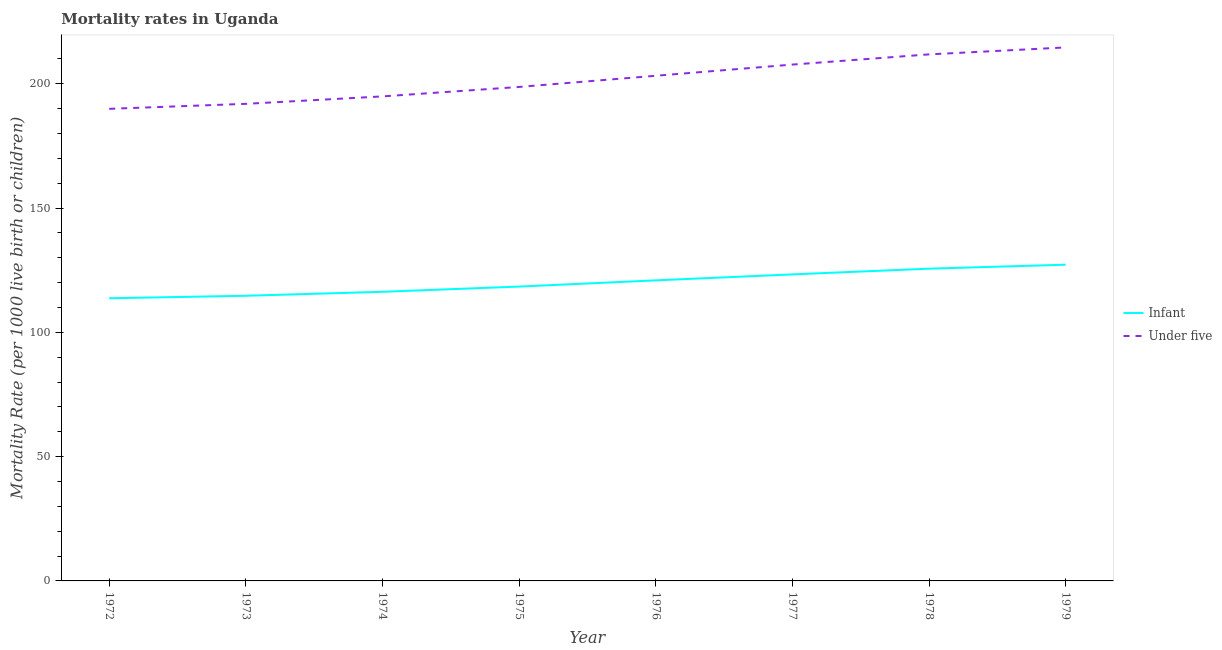How many different coloured lines are there?
Offer a very short reply. 2. Is the number of lines equal to the number of legend labels?
Your response must be concise. Yes. What is the under-5 mortality rate in 1976?
Keep it short and to the point. 203.2. Across all years, what is the maximum infant mortality rate?
Give a very brief answer. 127.2. Across all years, what is the minimum infant mortality rate?
Your response must be concise. 113.7. In which year was the infant mortality rate maximum?
Offer a terse response. 1979. What is the total under-5 mortality rate in the graph?
Provide a succinct answer. 1612.7. What is the difference between the under-5 mortality rate in 1972 and that in 1977?
Your response must be concise. -17.8. What is the difference between the under-5 mortality rate in 1974 and the infant mortality rate in 1973?
Ensure brevity in your answer.  80.2. What is the average infant mortality rate per year?
Provide a succinct answer. 120.01. In the year 1978, what is the difference between the under-5 mortality rate and infant mortality rate?
Keep it short and to the point. 86.2. What is the ratio of the infant mortality rate in 1977 to that in 1978?
Your answer should be very brief. 0.98. Is the under-5 mortality rate in 1973 less than that in 1975?
Your answer should be compact. Yes. Is the difference between the under-5 mortality rate in 1973 and 1978 greater than the difference between the infant mortality rate in 1973 and 1978?
Provide a succinct answer. No. What is the difference between the highest and the second highest infant mortality rate?
Provide a succinct answer. 1.6. In how many years, is the infant mortality rate greater than the average infant mortality rate taken over all years?
Keep it short and to the point. 4. Is the sum of the infant mortality rate in 1973 and 1979 greater than the maximum under-5 mortality rate across all years?
Keep it short and to the point. Yes. Is the infant mortality rate strictly greater than the under-5 mortality rate over the years?
Keep it short and to the point. No. What is the difference between two consecutive major ticks on the Y-axis?
Offer a terse response. 50. Are the values on the major ticks of Y-axis written in scientific E-notation?
Ensure brevity in your answer.  No. Does the graph contain any zero values?
Provide a short and direct response. No. Does the graph contain grids?
Your answer should be very brief. No. How many legend labels are there?
Ensure brevity in your answer.  2. How are the legend labels stacked?
Provide a short and direct response. Vertical. What is the title of the graph?
Offer a very short reply. Mortality rates in Uganda. Does "All education staff compensation" appear as one of the legend labels in the graph?
Provide a short and direct response. No. What is the label or title of the X-axis?
Provide a short and direct response. Year. What is the label or title of the Y-axis?
Give a very brief answer. Mortality Rate (per 1000 live birth or children). What is the Mortality Rate (per 1000 live birth or children) in Infant in 1972?
Offer a terse response. 113.7. What is the Mortality Rate (per 1000 live birth or children) of Under five in 1972?
Your response must be concise. 189.9. What is the Mortality Rate (per 1000 live birth or children) in Infant in 1973?
Ensure brevity in your answer.  114.7. What is the Mortality Rate (per 1000 live birth or children) in Under five in 1973?
Provide a short and direct response. 191.9. What is the Mortality Rate (per 1000 live birth or children) of Infant in 1974?
Your response must be concise. 116.3. What is the Mortality Rate (per 1000 live birth or children) in Under five in 1974?
Provide a short and direct response. 194.9. What is the Mortality Rate (per 1000 live birth or children) in Infant in 1975?
Offer a terse response. 118.4. What is the Mortality Rate (per 1000 live birth or children) in Under five in 1975?
Provide a succinct answer. 198.7. What is the Mortality Rate (per 1000 live birth or children) of Infant in 1976?
Give a very brief answer. 120.9. What is the Mortality Rate (per 1000 live birth or children) of Under five in 1976?
Provide a succinct answer. 203.2. What is the Mortality Rate (per 1000 live birth or children) in Infant in 1977?
Keep it short and to the point. 123.3. What is the Mortality Rate (per 1000 live birth or children) of Under five in 1977?
Your response must be concise. 207.7. What is the Mortality Rate (per 1000 live birth or children) of Infant in 1978?
Provide a short and direct response. 125.6. What is the Mortality Rate (per 1000 live birth or children) in Under five in 1978?
Your response must be concise. 211.8. What is the Mortality Rate (per 1000 live birth or children) of Infant in 1979?
Provide a short and direct response. 127.2. What is the Mortality Rate (per 1000 live birth or children) in Under five in 1979?
Your response must be concise. 214.6. Across all years, what is the maximum Mortality Rate (per 1000 live birth or children) in Infant?
Ensure brevity in your answer.  127.2. Across all years, what is the maximum Mortality Rate (per 1000 live birth or children) in Under five?
Provide a short and direct response. 214.6. Across all years, what is the minimum Mortality Rate (per 1000 live birth or children) of Infant?
Keep it short and to the point. 113.7. Across all years, what is the minimum Mortality Rate (per 1000 live birth or children) of Under five?
Keep it short and to the point. 189.9. What is the total Mortality Rate (per 1000 live birth or children) in Infant in the graph?
Offer a very short reply. 960.1. What is the total Mortality Rate (per 1000 live birth or children) of Under five in the graph?
Give a very brief answer. 1612.7. What is the difference between the Mortality Rate (per 1000 live birth or children) in Under five in 1972 and that in 1973?
Your answer should be very brief. -2. What is the difference between the Mortality Rate (per 1000 live birth or children) in Infant in 1972 and that in 1974?
Your response must be concise. -2.6. What is the difference between the Mortality Rate (per 1000 live birth or children) of Under five in 1972 and that in 1974?
Make the answer very short. -5. What is the difference between the Mortality Rate (per 1000 live birth or children) of Under five in 1972 and that in 1975?
Offer a very short reply. -8.8. What is the difference between the Mortality Rate (per 1000 live birth or children) of Infant in 1972 and that in 1976?
Give a very brief answer. -7.2. What is the difference between the Mortality Rate (per 1000 live birth or children) of Under five in 1972 and that in 1976?
Your answer should be very brief. -13.3. What is the difference between the Mortality Rate (per 1000 live birth or children) of Under five in 1972 and that in 1977?
Offer a terse response. -17.8. What is the difference between the Mortality Rate (per 1000 live birth or children) of Under five in 1972 and that in 1978?
Offer a terse response. -21.9. What is the difference between the Mortality Rate (per 1000 live birth or children) of Infant in 1972 and that in 1979?
Ensure brevity in your answer.  -13.5. What is the difference between the Mortality Rate (per 1000 live birth or children) in Under five in 1972 and that in 1979?
Make the answer very short. -24.7. What is the difference between the Mortality Rate (per 1000 live birth or children) in Infant in 1973 and that in 1974?
Your response must be concise. -1.6. What is the difference between the Mortality Rate (per 1000 live birth or children) of Infant in 1973 and that in 1975?
Your response must be concise. -3.7. What is the difference between the Mortality Rate (per 1000 live birth or children) of Under five in 1973 and that in 1976?
Provide a short and direct response. -11.3. What is the difference between the Mortality Rate (per 1000 live birth or children) of Under five in 1973 and that in 1977?
Your answer should be very brief. -15.8. What is the difference between the Mortality Rate (per 1000 live birth or children) in Infant in 1973 and that in 1978?
Your answer should be very brief. -10.9. What is the difference between the Mortality Rate (per 1000 live birth or children) of Under five in 1973 and that in 1978?
Your response must be concise. -19.9. What is the difference between the Mortality Rate (per 1000 live birth or children) of Infant in 1973 and that in 1979?
Provide a short and direct response. -12.5. What is the difference between the Mortality Rate (per 1000 live birth or children) in Under five in 1973 and that in 1979?
Provide a short and direct response. -22.7. What is the difference between the Mortality Rate (per 1000 live birth or children) of Infant in 1974 and that in 1975?
Your response must be concise. -2.1. What is the difference between the Mortality Rate (per 1000 live birth or children) of Under five in 1974 and that in 1975?
Give a very brief answer. -3.8. What is the difference between the Mortality Rate (per 1000 live birth or children) in Infant in 1974 and that in 1976?
Provide a short and direct response. -4.6. What is the difference between the Mortality Rate (per 1000 live birth or children) in Infant in 1974 and that in 1978?
Give a very brief answer. -9.3. What is the difference between the Mortality Rate (per 1000 live birth or children) of Under five in 1974 and that in 1978?
Your response must be concise. -16.9. What is the difference between the Mortality Rate (per 1000 live birth or children) in Infant in 1974 and that in 1979?
Ensure brevity in your answer.  -10.9. What is the difference between the Mortality Rate (per 1000 live birth or children) in Under five in 1974 and that in 1979?
Ensure brevity in your answer.  -19.7. What is the difference between the Mortality Rate (per 1000 live birth or children) in Infant in 1975 and that in 1976?
Give a very brief answer. -2.5. What is the difference between the Mortality Rate (per 1000 live birth or children) of Infant in 1975 and that in 1978?
Your answer should be compact. -7.2. What is the difference between the Mortality Rate (per 1000 live birth or children) of Under five in 1975 and that in 1978?
Provide a succinct answer. -13.1. What is the difference between the Mortality Rate (per 1000 live birth or children) in Infant in 1975 and that in 1979?
Your answer should be very brief. -8.8. What is the difference between the Mortality Rate (per 1000 live birth or children) in Under five in 1975 and that in 1979?
Make the answer very short. -15.9. What is the difference between the Mortality Rate (per 1000 live birth or children) of Infant in 1976 and that in 1977?
Offer a very short reply. -2.4. What is the difference between the Mortality Rate (per 1000 live birth or children) of Infant in 1976 and that in 1978?
Provide a short and direct response. -4.7. What is the difference between the Mortality Rate (per 1000 live birth or children) of Infant in 1976 and that in 1979?
Ensure brevity in your answer.  -6.3. What is the difference between the Mortality Rate (per 1000 live birth or children) in Under five in 1977 and that in 1978?
Your answer should be very brief. -4.1. What is the difference between the Mortality Rate (per 1000 live birth or children) in Infant in 1977 and that in 1979?
Your response must be concise. -3.9. What is the difference between the Mortality Rate (per 1000 live birth or children) of Infant in 1978 and that in 1979?
Your answer should be very brief. -1.6. What is the difference between the Mortality Rate (per 1000 live birth or children) in Under five in 1978 and that in 1979?
Your answer should be very brief. -2.8. What is the difference between the Mortality Rate (per 1000 live birth or children) in Infant in 1972 and the Mortality Rate (per 1000 live birth or children) in Under five in 1973?
Keep it short and to the point. -78.2. What is the difference between the Mortality Rate (per 1000 live birth or children) in Infant in 1972 and the Mortality Rate (per 1000 live birth or children) in Under five in 1974?
Your response must be concise. -81.2. What is the difference between the Mortality Rate (per 1000 live birth or children) in Infant in 1972 and the Mortality Rate (per 1000 live birth or children) in Under five in 1975?
Ensure brevity in your answer.  -85. What is the difference between the Mortality Rate (per 1000 live birth or children) of Infant in 1972 and the Mortality Rate (per 1000 live birth or children) of Under five in 1976?
Give a very brief answer. -89.5. What is the difference between the Mortality Rate (per 1000 live birth or children) of Infant in 1972 and the Mortality Rate (per 1000 live birth or children) of Under five in 1977?
Make the answer very short. -94. What is the difference between the Mortality Rate (per 1000 live birth or children) in Infant in 1972 and the Mortality Rate (per 1000 live birth or children) in Under five in 1978?
Ensure brevity in your answer.  -98.1. What is the difference between the Mortality Rate (per 1000 live birth or children) of Infant in 1972 and the Mortality Rate (per 1000 live birth or children) of Under five in 1979?
Offer a terse response. -100.9. What is the difference between the Mortality Rate (per 1000 live birth or children) in Infant in 1973 and the Mortality Rate (per 1000 live birth or children) in Under five in 1974?
Give a very brief answer. -80.2. What is the difference between the Mortality Rate (per 1000 live birth or children) of Infant in 1973 and the Mortality Rate (per 1000 live birth or children) of Under five in 1975?
Your response must be concise. -84. What is the difference between the Mortality Rate (per 1000 live birth or children) in Infant in 1973 and the Mortality Rate (per 1000 live birth or children) in Under five in 1976?
Your answer should be compact. -88.5. What is the difference between the Mortality Rate (per 1000 live birth or children) in Infant in 1973 and the Mortality Rate (per 1000 live birth or children) in Under five in 1977?
Provide a short and direct response. -93. What is the difference between the Mortality Rate (per 1000 live birth or children) in Infant in 1973 and the Mortality Rate (per 1000 live birth or children) in Under five in 1978?
Make the answer very short. -97.1. What is the difference between the Mortality Rate (per 1000 live birth or children) of Infant in 1973 and the Mortality Rate (per 1000 live birth or children) of Under five in 1979?
Provide a short and direct response. -99.9. What is the difference between the Mortality Rate (per 1000 live birth or children) in Infant in 1974 and the Mortality Rate (per 1000 live birth or children) in Under five in 1975?
Offer a terse response. -82.4. What is the difference between the Mortality Rate (per 1000 live birth or children) in Infant in 1974 and the Mortality Rate (per 1000 live birth or children) in Under five in 1976?
Your answer should be very brief. -86.9. What is the difference between the Mortality Rate (per 1000 live birth or children) of Infant in 1974 and the Mortality Rate (per 1000 live birth or children) of Under five in 1977?
Provide a succinct answer. -91.4. What is the difference between the Mortality Rate (per 1000 live birth or children) in Infant in 1974 and the Mortality Rate (per 1000 live birth or children) in Under five in 1978?
Ensure brevity in your answer.  -95.5. What is the difference between the Mortality Rate (per 1000 live birth or children) in Infant in 1974 and the Mortality Rate (per 1000 live birth or children) in Under five in 1979?
Your answer should be very brief. -98.3. What is the difference between the Mortality Rate (per 1000 live birth or children) of Infant in 1975 and the Mortality Rate (per 1000 live birth or children) of Under five in 1976?
Your response must be concise. -84.8. What is the difference between the Mortality Rate (per 1000 live birth or children) in Infant in 1975 and the Mortality Rate (per 1000 live birth or children) in Under five in 1977?
Your answer should be very brief. -89.3. What is the difference between the Mortality Rate (per 1000 live birth or children) in Infant in 1975 and the Mortality Rate (per 1000 live birth or children) in Under five in 1978?
Provide a succinct answer. -93.4. What is the difference between the Mortality Rate (per 1000 live birth or children) in Infant in 1975 and the Mortality Rate (per 1000 live birth or children) in Under five in 1979?
Ensure brevity in your answer.  -96.2. What is the difference between the Mortality Rate (per 1000 live birth or children) of Infant in 1976 and the Mortality Rate (per 1000 live birth or children) of Under five in 1977?
Give a very brief answer. -86.8. What is the difference between the Mortality Rate (per 1000 live birth or children) of Infant in 1976 and the Mortality Rate (per 1000 live birth or children) of Under five in 1978?
Your response must be concise. -90.9. What is the difference between the Mortality Rate (per 1000 live birth or children) of Infant in 1976 and the Mortality Rate (per 1000 live birth or children) of Under five in 1979?
Ensure brevity in your answer.  -93.7. What is the difference between the Mortality Rate (per 1000 live birth or children) in Infant in 1977 and the Mortality Rate (per 1000 live birth or children) in Under five in 1978?
Offer a terse response. -88.5. What is the difference between the Mortality Rate (per 1000 live birth or children) of Infant in 1977 and the Mortality Rate (per 1000 live birth or children) of Under five in 1979?
Ensure brevity in your answer.  -91.3. What is the difference between the Mortality Rate (per 1000 live birth or children) in Infant in 1978 and the Mortality Rate (per 1000 live birth or children) in Under five in 1979?
Provide a succinct answer. -89. What is the average Mortality Rate (per 1000 live birth or children) in Infant per year?
Offer a very short reply. 120.01. What is the average Mortality Rate (per 1000 live birth or children) in Under five per year?
Ensure brevity in your answer.  201.59. In the year 1972, what is the difference between the Mortality Rate (per 1000 live birth or children) of Infant and Mortality Rate (per 1000 live birth or children) of Under five?
Keep it short and to the point. -76.2. In the year 1973, what is the difference between the Mortality Rate (per 1000 live birth or children) of Infant and Mortality Rate (per 1000 live birth or children) of Under five?
Provide a succinct answer. -77.2. In the year 1974, what is the difference between the Mortality Rate (per 1000 live birth or children) in Infant and Mortality Rate (per 1000 live birth or children) in Under five?
Provide a succinct answer. -78.6. In the year 1975, what is the difference between the Mortality Rate (per 1000 live birth or children) of Infant and Mortality Rate (per 1000 live birth or children) of Under five?
Your response must be concise. -80.3. In the year 1976, what is the difference between the Mortality Rate (per 1000 live birth or children) of Infant and Mortality Rate (per 1000 live birth or children) of Under five?
Offer a very short reply. -82.3. In the year 1977, what is the difference between the Mortality Rate (per 1000 live birth or children) of Infant and Mortality Rate (per 1000 live birth or children) of Under five?
Give a very brief answer. -84.4. In the year 1978, what is the difference between the Mortality Rate (per 1000 live birth or children) in Infant and Mortality Rate (per 1000 live birth or children) in Under five?
Make the answer very short. -86.2. In the year 1979, what is the difference between the Mortality Rate (per 1000 live birth or children) in Infant and Mortality Rate (per 1000 live birth or children) in Under five?
Keep it short and to the point. -87.4. What is the ratio of the Mortality Rate (per 1000 live birth or children) in Infant in 1972 to that in 1974?
Give a very brief answer. 0.98. What is the ratio of the Mortality Rate (per 1000 live birth or children) of Under five in 1972 to that in 1974?
Ensure brevity in your answer.  0.97. What is the ratio of the Mortality Rate (per 1000 live birth or children) in Infant in 1972 to that in 1975?
Your response must be concise. 0.96. What is the ratio of the Mortality Rate (per 1000 live birth or children) of Under five in 1972 to that in 1975?
Keep it short and to the point. 0.96. What is the ratio of the Mortality Rate (per 1000 live birth or children) of Infant in 1972 to that in 1976?
Your response must be concise. 0.94. What is the ratio of the Mortality Rate (per 1000 live birth or children) of Under five in 1972 to that in 1976?
Your response must be concise. 0.93. What is the ratio of the Mortality Rate (per 1000 live birth or children) of Infant in 1972 to that in 1977?
Provide a succinct answer. 0.92. What is the ratio of the Mortality Rate (per 1000 live birth or children) in Under five in 1972 to that in 1977?
Give a very brief answer. 0.91. What is the ratio of the Mortality Rate (per 1000 live birth or children) of Infant in 1972 to that in 1978?
Your response must be concise. 0.91. What is the ratio of the Mortality Rate (per 1000 live birth or children) of Under five in 1972 to that in 1978?
Make the answer very short. 0.9. What is the ratio of the Mortality Rate (per 1000 live birth or children) of Infant in 1972 to that in 1979?
Provide a short and direct response. 0.89. What is the ratio of the Mortality Rate (per 1000 live birth or children) of Under five in 1972 to that in 1979?
Keep it short and to the point. 0.88. What is the ratio of the Mortality Rate (per 1000 live birth or children) in Infant in 1973 to that in 1974?
Offer a very short reply. 0.99. What is the ratio of the Mortality Rate (per 1000 live birth or children) in Under five in 1973 to that in 1974?
Your answer should be compact. 0.98. What is the ratio of the Mortality Rate (per 1000 live birth or children) in Infant in 1973 to that in 1975?
Your response must be concise. 0.97. What is the ratio of the Mortality Rate (per 1000 live birth or children) of Under five in 1973 to that in 1975?
Provide a short and direct response. 0.97. What is the ratio of the Mortality Rate (per 1000 live birth or children) of Infant in 1973 to that in 1976?
Keep it short and to the point. 0.95. What is the ratio of the Mortality Rate (per 1000 live birth or children) in Infant in 1973 to that in 1977?
Give a very brief answer. 0.93. What is the ratio of the Mortality Rate (per 1000 live birth or children) in Under five in 1973 to that in 1977?
Your answer should be very brief. 0.92. What is the ratio of the Mortality Rate (per 1000 live birth or children) in Infant in 1973 to that in 1978?
Offer a very short reply. 0.91. What is the ratio of the Mortality Rate (per 1000 live birth or children) of Under five in 1973 to that in 1978?
Your answer should be very brief. 0.91. What is the ratio of the Mortality Rate (per 1000 live birth or children) in Infant in 1973 to that in 1979?
Your answer should be compact. 0.9. What is the ratio of the Mortality Rate (per 1000 live birth or children) in Under five in 1973 to that in 1979?
Offer a very short reply. 0.89. What is the ratio of the Mortality Rate (per 1000 live birth or children) in Infant in 1974 to that in 1975?
Ensure brevity in your answer.  0.98. What is the ratio of the Mortality Rate (per 1000 live birth or children) in Under five in 1974 to that in 1975?
Your answer should be very brief. 0.98. What is the ratio of the Mortality Rate (per 1000 live birth or children) in Infant in 1974 to that in 1976?
Offer a very short reply. 0.96. What is the ratio of the Mortality Rate (per 1000 live birth or children) of Under five in 1974 to that in 1976?
Offer a very short reply. 0.96. What is the ratio of the Mortality Rate (per 1000 live birth or children) of Infant in 1974 to that in 1977?
Your response must be concise. 0.94. What is the ratio of the Mortality Rate (per 1000 live birth or children) of Under five in 1974 to that in 1977?
Provide a succinct answer. 0.94. What is the ratio of the Mortality Rate (per 1000 live birth or children) of Infant in 1974 to that in 1978?
Your answer should be very brief. 0.93. What is the ratio of the Mortality Rate (per 1000 live birth or children) in Under five in 1974 to that in 1978?
Make the answer very short. 0.92. What is the ratio of the Mortality Rate (per 1000 live birth or children) in Infant in 1974 to that in 1979?
Make the answer very short. 0.91. What is the ratio of the Mortality Rate (per 1000 live birth or children) of Under five in 1974 to that in 1979?
Make the answer very short. 0.91. What is the ratio of the Mortality Rate (per 1000 live birth or children) of Infant in 1975 to that in 1976?
Your answer should be compact. 0.98. What is the ratio of the Mortality Rate (per 1000 live birth or children) in Under five in 1975 to that in 1976?
Provide a succinct answer. 0.98. What is the ratio of the Mortality Rate (per 1000 live birth or children) of Infant in 1975 to that in 1977?
Your answer should be very brief. 0.96. What is the ratio of the Mortality Rate (per 1000 live birth or children) of Under five in 1975 to that in 1977?
Your response must be concise. 0.96. What is the ratio of the Mortality Rate (per 1000 live birth or children) in Infant in 1975 to that in 1978?
Your answer should be very brief. 0.94. What is the ratio of the Mortality Rate (per 1000 live birth or children) in Under five in 1975 to that in 1978?
Your answer should be compact. 0.94. What is the ratio of the Mortality Rate (per 1000 live birth or children) of Infant in 1975 to that in 1979?
Offer a terse response. 0.93. What is the ratio of the Mortality Rate (per 1000 live birth or children) of Under five in 1975 to that in 1979?
Offer a very short reply. 0.93. What is the ratio of the Mortality Rate (per 1000 live birth or children) of Infant in 1976 to that in 1977?
Give a very brief answer. 0.98. What is the ratio of the Mortality Rate (per 1000 live birth or children) in Under five in 1976 to that in 1977?
Give a very brief answer. 0.98. What is the ratio of the Mortality Rate (per 1000 live birth or children) in Infant in 1976 to that in 1978?
Make the answer very short. 0.96. What is the ratio of the Mortality Rate (per 1000 live birth or children) in Under five in 1976 to that in 1978?
Make the answer very short. 0.96. What is the ratio of the Mortality Rate (per 1000 live birth or children) in Infant in 1976 to that in 1979?
Ensure brevity in your answer.  0.95. What is the ratio of the Mortality Rate (per 1000 live birth or children) of Under five in 1976 to that in 1979?
Offer a terse response. 0.95. What is the ratio of the Mortality Rate (per 1000 live birth or children) of Infant in 1977 to that in 1978?
Provide a succinct answer. 0.98. What is the ratio of the Mortality Rate (per 1000 live birth or children) in Under five in 1977 to that in 1978?
Keep it short and to the point. 0.98. What is the ratio of the Mortality Rate (per 1000 live birth or children) of Infant in 1977 to that in 1979?
Offer a very short reply. 0.97. What is the ratio of the Mortality Rate (per 1000 live birth or children) in Under five in 1977 to that in 1979?
Keep it short and to the point. 0.97. What is the ratio of the Mortality Rate (per 1000 live birth or children) of Infant in 1978 to that in 1979?
Offer a very short reply. 0.99. What is the difference between the highest and the second highest Mortality Rate (per 1000 live birth or children) in Infant?
Make the answer very short. 1.6. What is the difference between the highest and the second highest Mortality Rate (per 1000 live birth or children) in Under five?
Offer a very short reply. 2.8. What is the difference between the highest and the lowest Mortality Rate (per 1000 live birth or children) in Under five?
Your answer should be very brief. 24.7. 